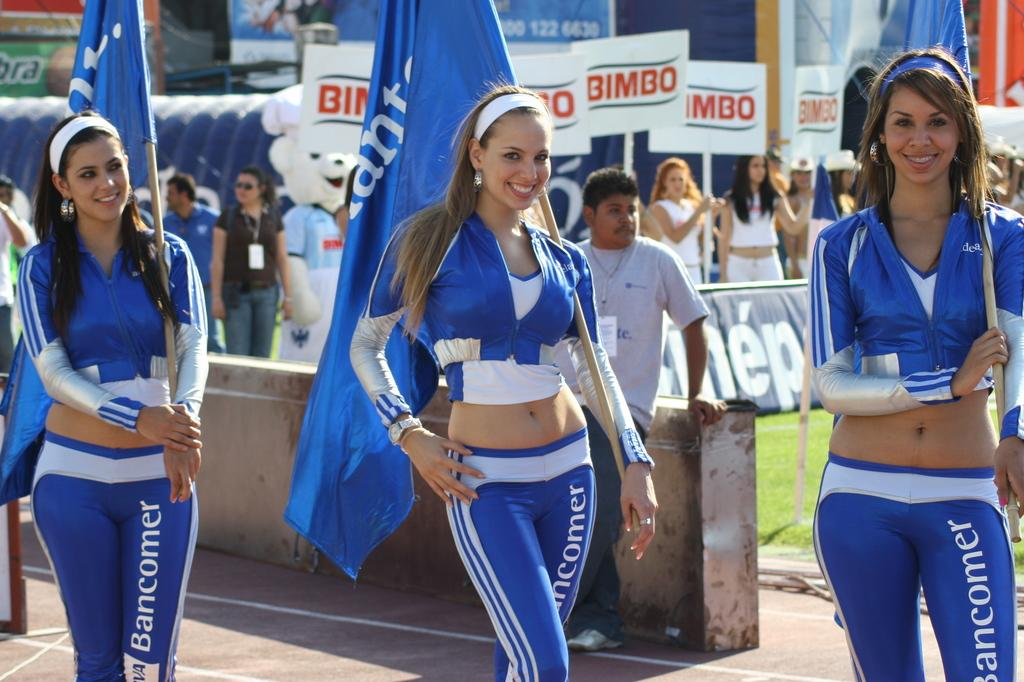Provide a one-sentence caption for the provided image. Three promo girls for bancomer wearing blue tight uniforms are posing for the picture. 